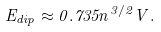Convert formula to latex. <formula><loc_0><loc_0><loc_500><loc_500>E _ { d i p } \approx 0 . 7 3 5 n ^ { 3 / 2 } V .</formula> 